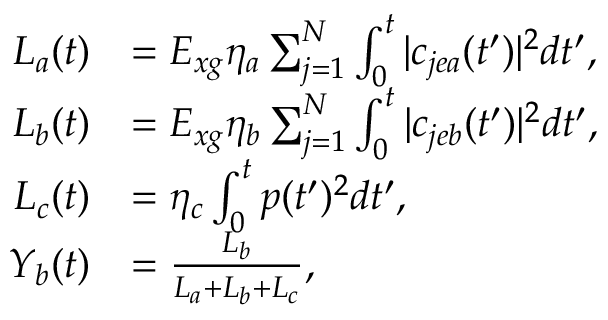<formula> <loc_0><loc_0><loc_500><loc_500>\begin{array} { r l } { L _ { a } ( t ) } & { = E _ { x g } \eta _ { a } \sum _ { j = 1 } ^ { N } \int _ { 0 } ^ { t } | c _ { j e a } ( t ^ { \prime } ) | ^ { 2 } d t ^ { \prime } , } \\ { L _ { b } ( t ) } & { = E _ { x g } \eta _ { b } \sum _ { j = 1 } ^ { N } \int _ { 0 } ^ { t } | c _ { j e b } ( t ^ { \prime } ) | ^ { 2 } d t ^ { \prime } , } \\ { L _ { c } ( t ) } & { = \eta _ { c } \int _ { 0 } ^ { t } p ( t ^ { \prime } ) ^ { 2 } d t ^ { \prime } , } \\ { Y _ { b } ( t ) } & { = \frac { L _ { b } } { L _ { a } + L _ { b } + L _ { c } } , } \end{array}</formula> 